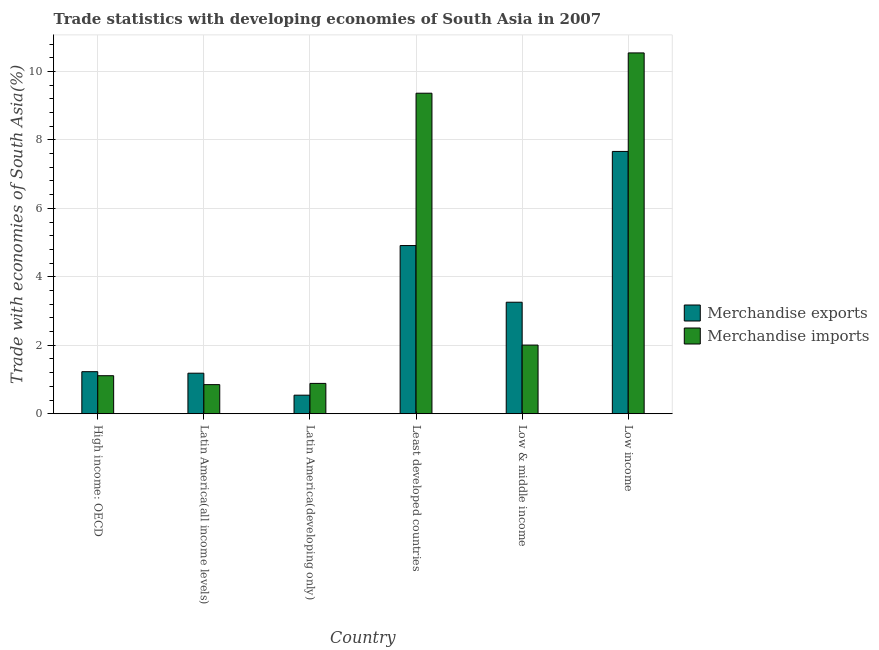How many different coloured bars are there?
Your response must be concise. 2. How many groups of bars are there?
Your answer should be compact. 6. Are the number of bars per tick equal to the number of legend labels?
Offer a terse response. Yes. Are the number of bars on each tick of the X-axis equal?
Provide a succinct answer. Yes. How many bars are there on the 5th tick from the left?
Offer a terse response. 2. How many bars are there on the 1st tick from the right?
Offer a terse response. 2. What is the label of the 5th group of bars from the left?
Your answer should be compact. Low & middle income. What is the merchandise imports in Least developed countries?
Give a very brief answer. 9.36. Across all countries, what is the maximum merchandise exports?
Provide a short and direct response. 7.66. Across all countries, what is the minimum merchandise imports?
Offer a very short reply. 0.85. In which country was the merchandise exports maximum?
Provide a short and direct response. Low income. In which country was the merchandise exports minimum?
Your answer should be very brief. Latin America(developing only). What is the total merchandise imports in the graph?
Your answer should be compact. 24.76. What is the difference between the merchandise exports in Latin America(developing only) and that in Least developed countries?
Provide a short and direct response. -4.37. What is the difference between the merchandise imports in Latin America(developing only) and the merchandise exports in Least developed countries?
Give a very brief answer. -4.03. What is the average merchandise exports per country?
Keep it short and to the point. 3.13. What is the difference between the merchandise imports and merchandise exports in High income: OECD?
Your answer should be compact. -0.12. What is the ratio of the merchandise exports in High income: OECD to that in Latin America(all income levels)?
Make the answer very short. 1.04. What is the difference between the highest and the second highest merchandise exports?
Your answer should be compact. 2.75. What is the difference between the highest and the lowest merchandise exports?
Your answer should be very brief. 7.12. Is the sum of the merchandise imports in Latin America(developing only) and Least developed countries greater than the maximum merchandise exports across all countries?
Provide a short and direct response. Yes. What does the 1st bar from the left in Low income represents?
Provide a short and direct response. Merchandise exports. What does the 1st bar from the right in Latin America(all income levels) represents?
Keep it short and to the point. Merchandise imports. How many countries are there in the graph?
Your response must be concise. 6. What is the difference between two consecutive major ticks on the Y-axis?
Keep it short and to the point. 2. Are the values on the major ticks of Y-axis written in scientific E-notation?
Offer a very short reply. No. Does the graph contain any zero values?
Your answer should be very brief. No. Does the graph contain grids?
Offer a very short reply. Yes. Where does the legend appear in the graph?
Your answer should be very brief. Center right. What is the title of the graph?
Offer a very short reply. Trade statistics with developing economies of South Asia in 2007. Does "Secondary Education" appear as one of the legend labels in the graph?
Your response must be concise. No. What is the label or title of the X-axis?
Offer a terse response. Country. What is the label or title of the Y-axis?
Your answer should be very brief. Trade with economies of South Asia(%). What is the Trade with economies of South Asia(%) in Merchandise exports in High income: OECD?
Ensure brevity in your answer.  1.23. What is the Trade with economies of South Asia(%) in Merchandise imports in High income: OECD?
Offer a very short reply. 1.11. What is the Trade with economies of South Asia(%) of Merchandise exports in Latin America(all income levels)?
Your answer should be very brief. 1.18. What is the Trade with economies of South Asia(%) in Merchandise imports in Latin America(all income levels)?
Your answer should be compact. 0.85. What is the Trade with economies of South Asia(%) in Merchandise exports in Latin America(developing only)?
Make the answer very short. 0.54. What is the Trade with economies of South Asia(%) of Merchandise imports in Latin America(developing only)?
Make the answer very short. 0.89. What is the Trade with economies of South Asia(%) of Merchandise exports in Least developed countries?
Ensure brevity in your answer.  4.91. What is the Trade with economies of South Asia(%) of Merchandise imports in Least developed countries?
Offer a terse response. 9.36. What is the Trade with economies of South Asia(%) in Merchandise exports in Low & middle income?
Offer a terse response. 3.26. What is the Trade with economies of South Asia(%) of Merchandise imports in Low & middle income?
Make the answer very short. 2.01. What is the Trade with economies of South Asia(%) in Merchandise exports in Low income?
Make the answer very short. 7.66. What is the Trade with economies of South Asia(%) of Merchandise imports in Low income?
Your answer should be compact. 10.54. Across all countries, what is the maximum Trade with economies of South Asia(%) in Merchandise exports?
Give a very brief answer. 7.66. Across all countries, what is the maximum Trade with economies of South Asia(%) of Merchandise imports?
Keep it short and to the point. 10.54. Across all countries, what is the minimum Trade with economies of South Asia(%) in Merchandise exports?
Keep it short and to the point. 0.54. Across all countries, what is the minimum Trade with economies of South Asia(%) of Merchandise imports?
Provide a succinct answer. 0.85. What is the total Trade with economies of South Asia(%) of Merchandise exports in the graph?
Offer a terse response. 18.79. What is the total Trade with economies of South Asia(%) in Merchandise imports in the graph?
Provide a short and direct response. 24.76. What is the difference between the Trade with economies of South Asia(%) in Merchandise exports in High income: OECD and that in Latin America(all income levels)?
Provide a short and direct response. 0.04. What is the difference between the Trade with economies of South Asia(%) of Merchandise imports in High income: OECD and that in Latin America(all income levels)?
Your answer should be compact. 0.26. What is the difference between the Trade with economies of South Asia(%) in Merchandise exports in High income: OECD and that in Latin America(developing only)?
Your answer should be very brief. 0.69. What is the difference between the Trade with economies of South Asia(%) in Merchandise imports in High income: OECD and that in Latin America(developing only)?
Give a very brief answer. 0.22. What is the difference between the Trade with economies of South Asia(%) of Merchandise exports in High income: OECD and that in Least developed countries?
Provide a short and direct response. -3.68. What is the difference between the Trade with economies of South Asia(%) of Merchandise imports in High income: OECD and that in Least developed countries?
Your response must be concise. -8.25. What is the difference between the Trade with economies of South Asia(%) of Merchandise exports in High income: OECD and that in Low & middle income?
Provide a succinct answer. -2.03. What is the difference between the Trade with economies of South Asia(%) in Merchandise imports in High income: OECD and that in Low & middle income?
Ensure brevity in your answer.  -0.9. What is the difference between the Trade with economies of South Asia(%) of Merchandise exports in High income: OECD and that in Low income?
Provide a succinct answer. -6.43. What is the difference between the Trade with economies of South Asia(%) in Merchandise imports in High income: OECD and that in Low income?
Offer a very short reply. -9.43. What is the difference between the Trade with economies of South Asia(%) in Merchandise exports in Latin America(all income levels) and that in Latin America(developing only)?
Your answer should be compact. 0.64. What is the difference between the Trade with economies of South Asia(%) of Merchandise imports in Latin America(all income levels) and that in Latin America(developing only)?
Ensure brevity in your answer.  -0.04. What is the difference between the Trade with economies of South Asia(%) in Merchandise exports in Latin America(all income levels) and that in Least developed countries?
Provide a succinct answer. -3.73. What is the difference between the Trade with economies of South Asia(%) of Merchandise imports in Latin America(all income levels) and that in Least developed countries?
Your response must be concise. -8.51. What is the difference between the Trade with economies of South Asia(%) in Merchandise exports in Latin America(all income levels) and that in Low & middle income?
Offer a terse response. -2.07. What is the difference between the Trade with economies of South Asia(%) in Merchandise imports in Latin America(all income levels) and that in Low & middle income?
Ensure brevity in your answer.  -1.16. What is the difference between the Trade with economies of South Asia(%) of Merchandise exports in Latin America(all income levels) and that in Low income?
Your answer should be compact. -6.48. What is the difference between the Trade with economies of South Asia(%) in Merchandise imports in Latin America(all income levels) and that in Low income?
Your answer should be compact. -9.69. What is the difference between the Trade with economies of South Asia(%) of Merchandise exports in Latin America(developing only) and that in Least developed countries?
Your response must be concise. -4.37. What is the difference between the Trade with economies of South Asia(%) of Merchandise imports in Latin America(developing only) and that in Least developed countries?
Your answer should be very brief. -8.48. What is the difference between the Trade with economies of South Asia(%) in Merchandise exports in Latin America(developing only) and that in Low & middle income?
Your answer should be very brief. -2.72. What is the difference between the Trade with economies of South Asia(%) of Merchandise imports in Latin America(developing only) and that in Low & middle income?
Your answer should be very brief. -1.12. What is the difference between the Trade with economies of South Asia(%) of Merchandise exports in Latin America(developing only) and that in Low income?
Provide a short and direct response. -7.12. What is the difference between the Trade with economies of South Asia(%) of Merchandise imports in Latin America(developing only) and that in Low income?
Your answer should be very brief. -9.65. What is the difference between the Trade with economies of South Asia(%) of Merchandise exports in Least developed countries and that in Low & middle income?
Keep it short and to the point. 1.66. What is the difference between the Trade with economies of South Asia(%) of Merchandise imports in Least developed countries and that in Low & middle income?
Keep it short and to the point. 7.36. What is the difference between the Trade with economies of South Asia(%) in Merchandise exports in Least developed countries and that in Low income?
Give a very brief answer. -2.75. What is the difference between the Trade with economies of South Asia(%) in Merchandise imports in Least developed countries and that in Low income?
Your answer should be very brief. -1.18. What is the difference between the Trade with economies of South Asia(%) of Merchandise exports in Low & middle income and that in Low income?
Offer a very short reply. -4.41. What is the difference between the Trade with economies of South Asia(%) of Merchandise imports in Low & middle income and that in Low income?
Offer a very short reply. -8.53. What is the difference between the Trade with economies of South Asia(%) in Merchandise exports in High income: OECD and the Trade with economies of South Asia(%) in Merchandise imports in Latin America(all income levels)?
Provide a succinct answer. 0.38. What is the difference between the Trade with economies of South Asia(%) of Merchandise exports in High income: OECD and the Trade with economies of South Asia(%) of Merchandise imports in Latin America(developing only)?
Offer a very short reply. 0.34. What is the difference between the Trade with economies of South Asia(%) in Merchandise exports in High income: OECD and the Trade with economies of South Asia(%) in Merchandise imports in Least developed countries?
Make the answer very short. -8.13. What is the difference between the Trade with economies of South Asia(%) in Merchandise exports in High income: OECD and the Trade with economies of South Asia(%) in Merchandise imports in Low & middle income?
Provide a short and direct response. -0.78. What is the difference between the Trade with economies of South Asia(%) of Merchandise exports in High income: OECD and the Trade with economies of South Asia(%) of Merchandise imports in Low income?
Give a very brief answer. -9.31. What is the difference between the Trade with economies of South Asia(%) of Merchandise exports in Latin America(all income levels) and the Trade with economies of South Asia(%) of Merchandise imports in Latin America(developing only)?
Give a very brief answer. 0.3. What is the difference between the Trade with economies of South Asia(%) in Merchandise exports in Latin America(all income levels) and the Trade with economies of South Asia(%) in Merchandise imports in Least developed countries?
Offer a very short reply. -8.18. What is the difference between the Trade with economies of South Asia(%) of Merchandise exports in Latin America(all income levels) and the Trade with economies of South Asia(%) of Merchandise imports in Low & middle income?
Offer a terse response. -0.82. What is the difference between the Trade with economies of South Asia(%) in Merchandise exports in Latin America(all income levels) and the Trade with economies of South Asia(%) in Merchandise imports in Low income?
Keep it short and to the point. -9.36. What is the difference between the Trade with economies of South Asia(%) of Merchandise exports in Latin America(developing only) and the Trade with economies of South Asia(%) of Merchandise imports in Least developed countries?
Ensure brevity in your answer.  -8.82. What is the difference between the Trade with economies of South Asia(%) in Merchandise exports in Latin America(developing only) and the Trade with economies of South Asia(%) in Merchandise imports in Low & middle income?
Provide a succinct answer. -1.46. What is the difference between the Trade with economies of South Asia(%) in Merchandise exports in Latin America(developing only) and the Trade with economies of South Asia(%) in Merchandise imports in Low income?
Keep it short and to the point. -10. What is the difference between the Trade with economies of South Asia(%) in Merchandise exports in Least developed countries and the Trade with economies of South Asia(%) in Merchandise imports in Low & middle income?
Ensure brevity in your answer.  2.91. What is the difference between the Trade with economies of South Asia(%) in Merchandise exports in Least developed countries and the Trade with economies of South Asia(%) in Merchandise imports in Low income?
Your answer should be very brief. -5.63. What is the difference between the Trade with economies of South Asia(%) of Merchandise exports in Low & middle income and the Trade with economies of South Asia(%) of Merchandise imports in Low income?
Offer a terse response. -7.28. What is the average Trade with economies of South Asia(%) of Merchandise exports per country?
Ensure brevity in your answer.  3.13. What is the average Trade with economies of South Asia(%) in Merchandise imports per country?
Your response must be concise. 4.13. What is the difference between the Trade with economies of South Asia(%) of Merchandise exports and Trade with economies of South Asia(%) of Merchandise imports in High income: OECD?
Your answer should be compact. 0.12. What is the difference between the Trade with economies of South Asia(%) of Merchandise exports and Trade with economies of South Asia(%) of Merchandise imports in Latin America(all income levels)?
Ensure brevity in your answer.  0.33. What is the difference between the Trade with economies of South Asia(%) in Merchandise exports and Trade with economies of South Asia(%) in Merchandise imports in Latin America(developing only)?
Offer a very short reply. -0.34. What is the difference between the Trade with economies of South Asia(%) in Merchandise exports and Trade with economies of South Asia(%) in Merchandise imports in Least developed countries?
Provide a short and direct response. -4.45. What is the difference between the Trade with economies of South Asia(%) in Merchandise exports and Trade with economies of South Asia(%) in Merchandise imports in Low & middle income?
Your answer should be compact. 1.25. What is the difference between the Trade with economies of South Asia(%) of Merchandise exports and Trade with economies of South Asia(%) of Merchandise imports in Low income?
Ensure brevity in your answer.  -2.88. What is the ratio of the Trade with economies of South Asia(%) in Merchandise exports in High income: OECD to that in Latin America(all income levels)?
Your response must be concise. 1.04. What is the ratio of the Trade with economies of South Asia(%) in Merchandise imports in High income: OECD to that in Latin America(all income levels)?
Your answer should be compact. 1.31. What is the ratio of the Trade with economies of South Asia(%) in Merchandise exports in High income: OECD to that in Latin America(developing only)?
Offer a very short reply. 2.27. What is the ratio of the Trade with economies of South Asia(%) in Merchandise imports in High income: OECD to that in Latin America(developing only)?
Your response must be concise. 1.25. What is the ratio of the Trade with economies of South Asia(%) in Merchandise exports in High income: OECD to that in Least developed countries?
Provide a succinct answer. 0.25. What is the ratio of the Trade with economies of South Asia(%) of Merchandise imports in High income: OECD to that in Least developed countries?
Your answer should be very brief. 0.12. What is the ratio of the Trade with economies of South Asia(%) of Merchandise exports in High income: OECD to that in Low & middle income?
Your answer should be compact. 0.38. What is the ratio of the Trade with economies of South Asia(%) in Merchandise imports in High income: OECD to that in Low & middle income?
Provide a short and direct response. 0.55. What is the ratio of the Trade with economies of South Asia(%) of Merchandise exports in High income: OECD to that in Low income?
Make the answer very short. 0.16. What is the ratio of the Trade with economies of South Asia(%) in Merchandise imports in High income: OECD to that in Low income?
Make the answer very short. 0.11. What is the ratio of the Trade with economies of South Asia(%) of Merchandise exports in Latin America(all income levels) to that in Latin America(developing only)?
Ensure brevity in your answer.  2.18. What is the ratio of the Trade with economies of South Asia(%) in Merchandise imports in Latin America(all income levels) to that in Latin America(developing only)?
Your response must be concise. 0.96. What is the ratio of the Trade with economies of South Asia(%) in Merchandise exports in Latin America(all income levels) to that in Least developed countries?
Ensure brevity in your answer.  0.24. What is the ratio of the Trade with economies of South Asia(%) of Merchandise imports in Latin America(all income levels) to that in Least developed countries?
Give a very brief answer. 0.09. What is the ratio of the Trade with economies of South Asia(%) in Merchandise exports in Latin America(all income levels) to that in Low & middle income?
Your response must be concise. 0.36. What is the ratio of the Trade with economies of South Asia(%) in Merchandise imports in Latin America(all income levels) to that in Low & middle income?
Offer a terse response. 0.42. What is the ratio of the Trade with economies of South Asia(%) of Merchandise exports in Latin America(all income levels) to that in Low income?
Ensure brevity in your answer.  0.15. What is the ratio of the Trade with economies of South Asia(%) of Merchandise imports in Latin America(all income levels) to that in Low income?
Ensure brevity in your answer.  0.08. What is the ratio of the Trade with economies of South Asia(%) of Merchandise exports in Latin America(developing only) to that in Least developed countries?
Offer a terse response. 0.11. What is the ratio of the Trade with economies of South Asia(%) in Merchandise imports in Latin America(developing only) to that in Least developed countries?
Offer a terse response. 0.09. What is the ratio of the Trade with economies of South Asia(%) in Merchandise exports in Latin America(developing only) to that in Low & middle income?
Provide a short and direct response. 0.17. What is the ratio of the Trade with economies of South Asia(%) of Merchandise imports in Latin America(developing only) to that in Low & middle income?
Ensure brevity in your answer.  0.44. What is the ratio of the Trade with economies of South Asia(%) of Merchandise exports in Latin America(developing only) to that in Low income?
Keep it short and to the point. 0.07. What is the ratio of the Trade with economies of South Asia(%) of Merchandise imports in Latin America(developing only) to that in Low income?
Provide a short and direct response. 0.08. What is the ratio of the Trade with economies of South Asia(%) of Merchandise exports in Least developed countries to that in Low & middle income?
Offer a very short reply. 1.51. What is the ratio of the Trade with economies of South Asia(%) in Merchandise imports in Least developed countries to that in Low & middle income?
Give a very brief answer. 4.67. What is the ratio of the Trade with economies of South Asia(%) in Merchandise exports in Least developed countries to that in Low income?
Your answer should be very brief. 0.64. What is the ratio of the Trade with economies of South Asia(%) in Merchandise imports in Least developed countries to that in Low income?
Offer a terse response. 0.89. What is the ratio of the Trade with economies of South Asia(%) in Merchandise exports in Low & middle income to that in Low income?
Your answer should be very brief. 0.43. What is the ratio of the Trade with economies of South Asia(%) in Merchandise imports in Low & middle income to that in Low income?
Your response must be concise. 0.19. What is the difference between the highest and the second highest Trade with economies of South Asia(%) in Merchandise exports?
Your answer should be very brief. 2.75. What is the difference between the highest and the second highest Trade with economies of South Asia(%) of Merchandise imports?
Your response must be concise. 1.18. What is the difference between the highest and the lowest Trade with economies of South Asia(%) of Merchandise exports?
Keep it short and to the point. 7.12. What is the difference between the highest and the lowest Trade with economies of South Asia(%) of Merchandise imports?
Ensure brevity in your answer.  9.69. 